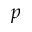<formula> <loc_0><loc_0><loc_500><loc_500>p</formula> 